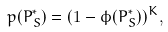Convert formula to latex. <formula><loc_0><loc_0><loc_500><loc_500>p ( P _ { S } ^ { * } ) = ( 1 - \phi ( P _ { S } ^ { * } ) ) ^ { K } ,</formula> 